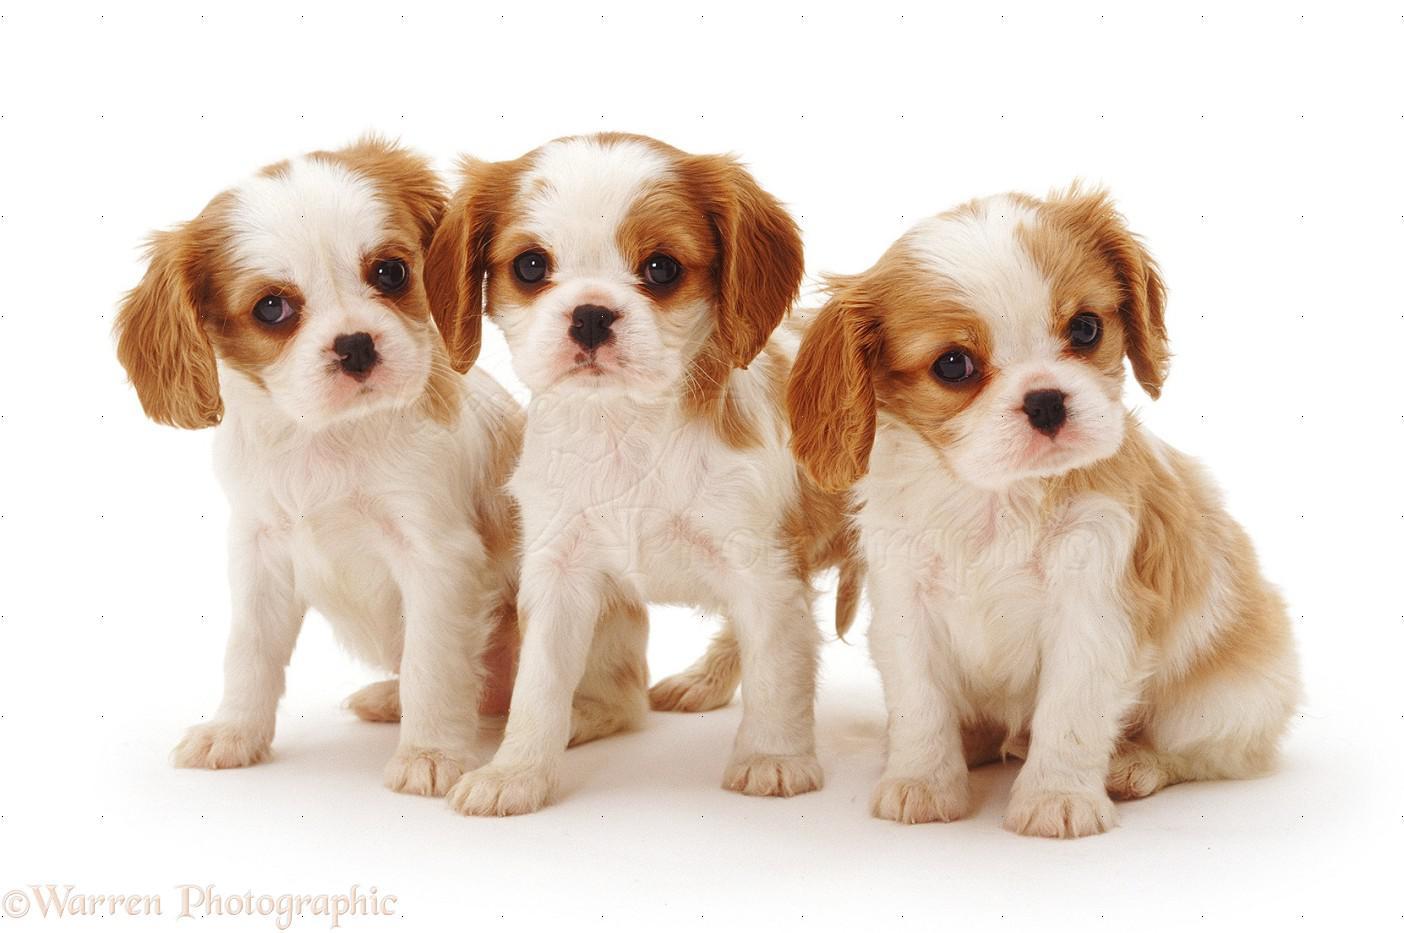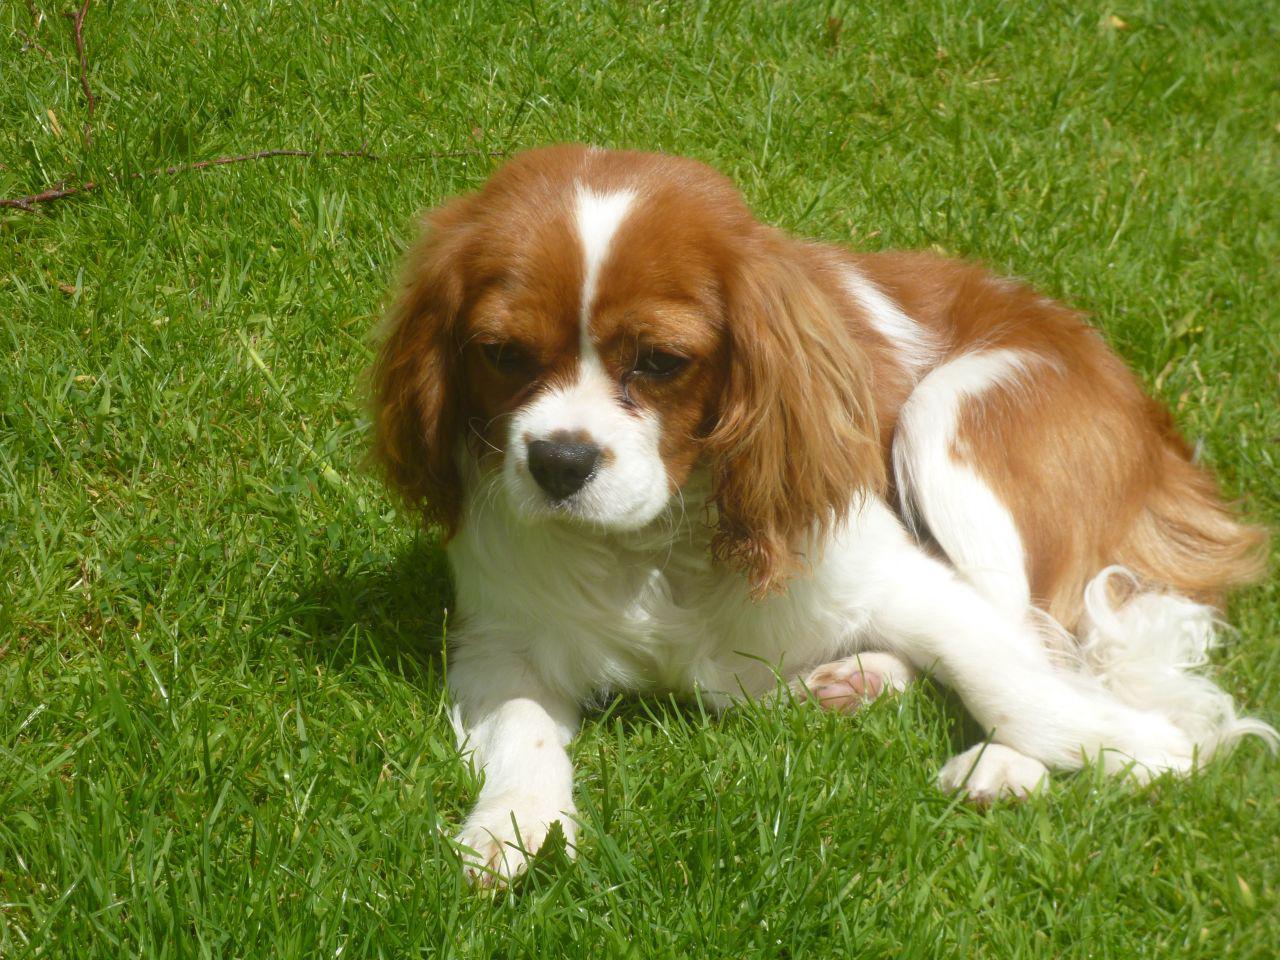The first image is the image on the left, the second image is the image on the right. Considering the images on both sides, is "There are three dogs" valid? Answer yes or no. No. 